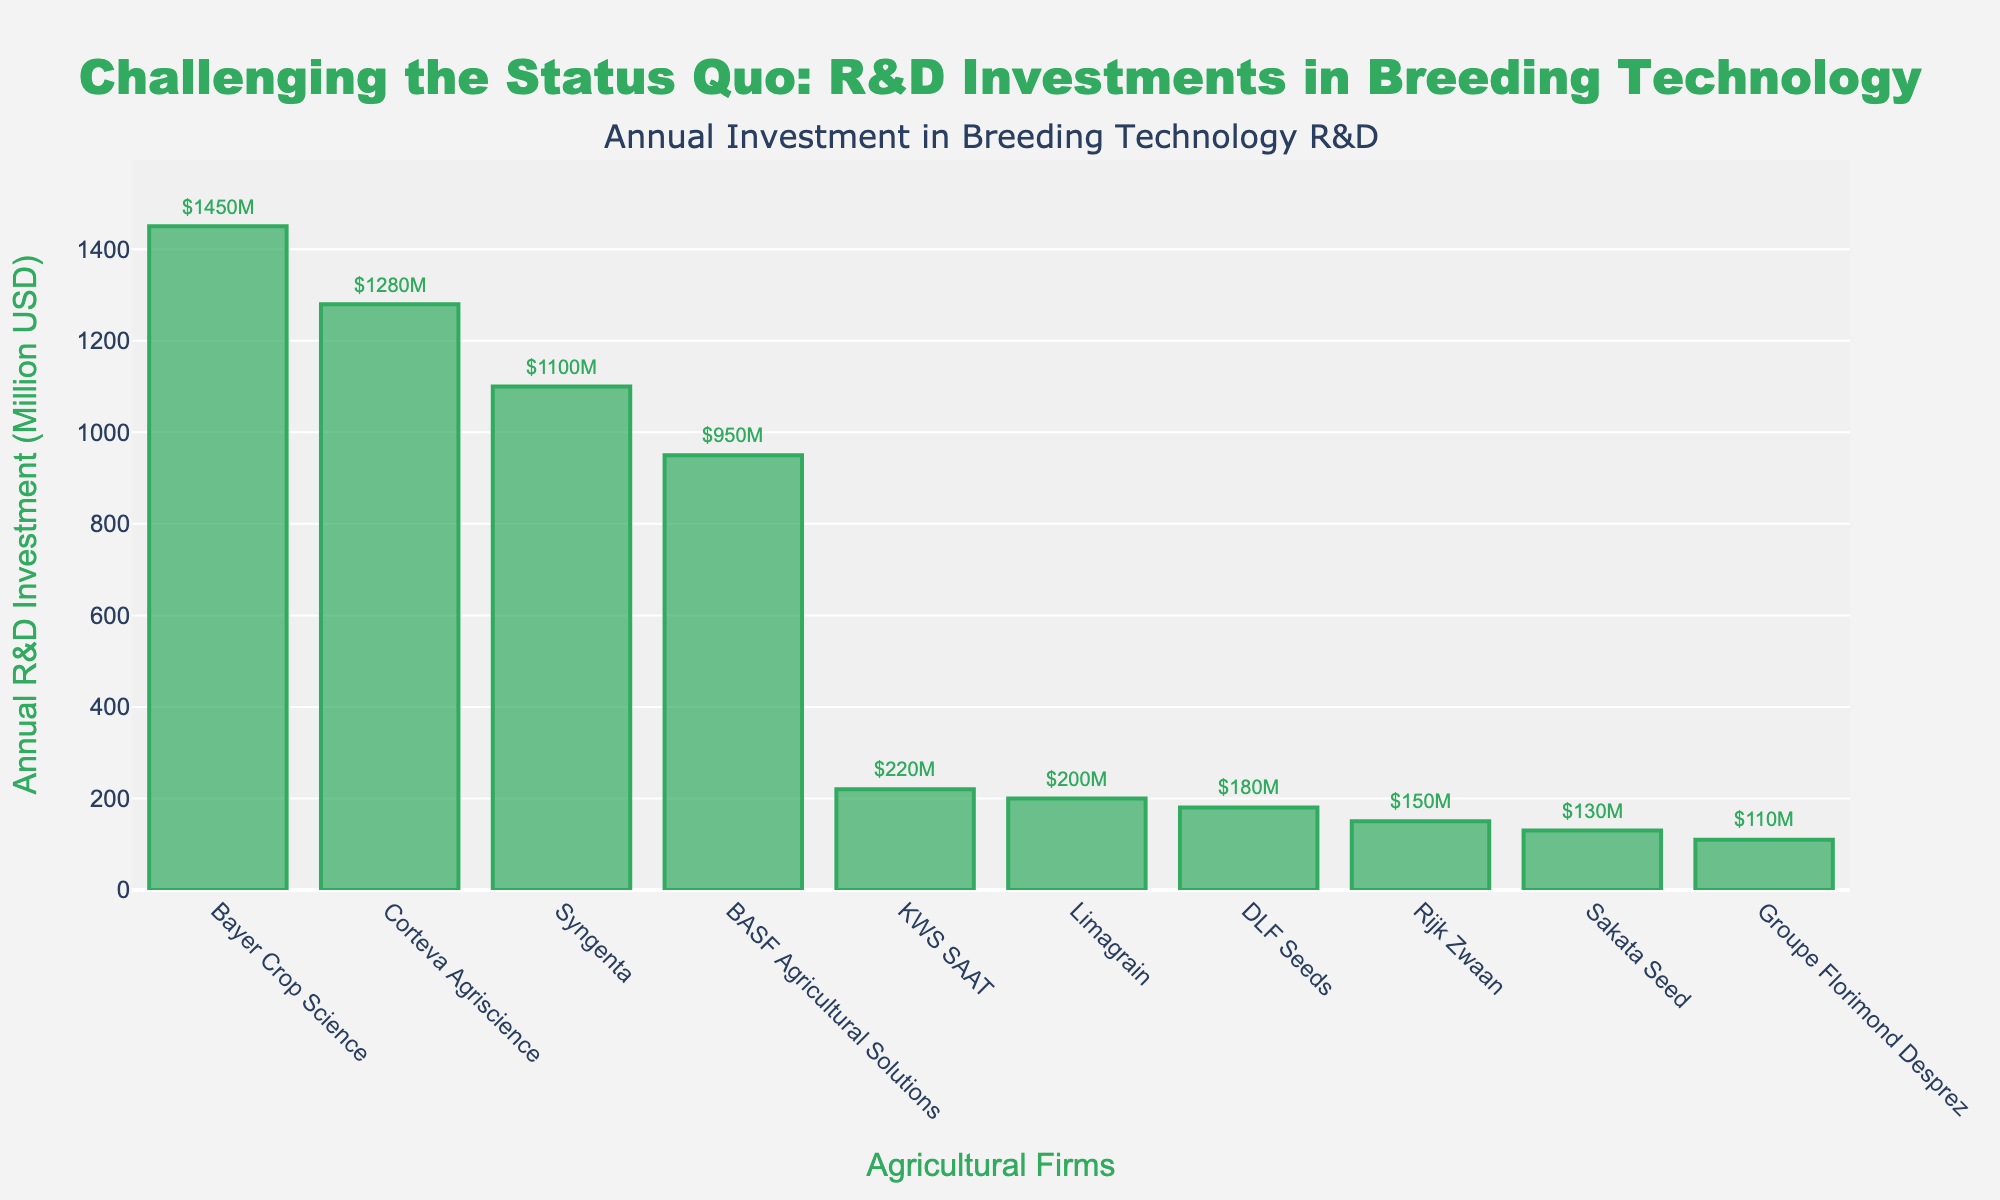What's the total R&D investment by Bayer Crop Science and Corteva Agriscience? To find the total R&D investment by Bayer Crop Science and Corteva Agriscience, sum their individual investments: Bayer Crop Science ($1450 Million) and Corteva Agriscience ($1280 Million). So, 1450 + 1280 = 2730 Million USD.
Answer: 2730 Million USD Which company has the lowest R&D investment? To find the company with the lowest R&D investment, look for the shortest bar in the chart, which represents the smallest investment value. The shortest bar corresponds to Groupe Florimond Desprez with an investment of 110 Million USD.
Answer: Groupe Florimond Desprez How much more is the R&D investment of Syngenta compared to BASF Agricultural Solutions? To find the difference, subtract the investment of BASF Agricultural Solutions ($950 Million) from Syngenta's investment ($1100 Million). So, 1100 - 950 = 150 Million USD.
Answer: 150 Million USD What's the average R&D investment of the top three companies? To find the average investment of the top three companies (Bayer Crop Science, Corteva Agriscience, and Syngenta), sum their investments and divide by 3: (1450 + 1280 + 1100) / 3 = 3830 / 3 ≈ 1276.67 Million USD.
Answer: 1276.67 Million USD Are there any companies with an R&D investment below 200 Million USD? Look for bars representing investments below the 200 Million USD mark. There are three such companies: KWS SAAT ($220 Million), Limagrain ($200 Million), DLF Seeds ($180 Million), Rijk Zwaan ($150 Million), and Sakata Seed ($130 Million), and Groupe Florimond Desprez ($110 Million).
Answer: Yes What is the combined R&D investment of the companies with R&D investments above 1000 Million USD? Identify the companies with investments above 1000 Million USD: Bayer Crop Science, Corteva Agriscience, and Syngenta. Sum their investments: 1450 + 1280 + 1100 = 3830 Million USD.
Answer: 3830 Million USD Which companies have an investment difference of less than 50 Million USD when compared to Limagrain? Limagrain has an investment of 200 Million USD. Companies with investments within +/- 50 Million USD of 200 are KWS SAAT ($220 Million), DLF Seeds ($180 Million), and Limagrain itself ($200 Million).
Answer: KWS SAAT and DLF Seeds 